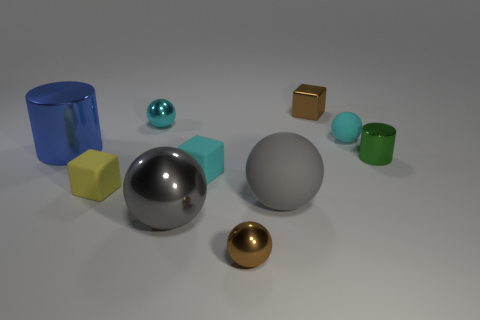Subtract all big metallic balls. How many balls are left? 4 Subtract all red cylinders. How many cyan spheres are left? 2 Subtract all cyan cubes. How many cubes are left? 2 Subtract 1 cubes. How many cubes are left? 2 Subtract all blocks. How many objects are left? 7 Subtract 0 gray cylinders. How many objects are left? 10 Subtract all yellow cylinders. Subtract all purple blocks. How many cylinders are left? 2 Subtract all tiny cylinders. Subtract all tiny brown shiny spheres. How many objects are left? 8 Add 9 small green cylinders. How many small green cylinders are left? 10 Add 1 tiny blue shiny objects. How many tiny blue shiny objects exist? 1 